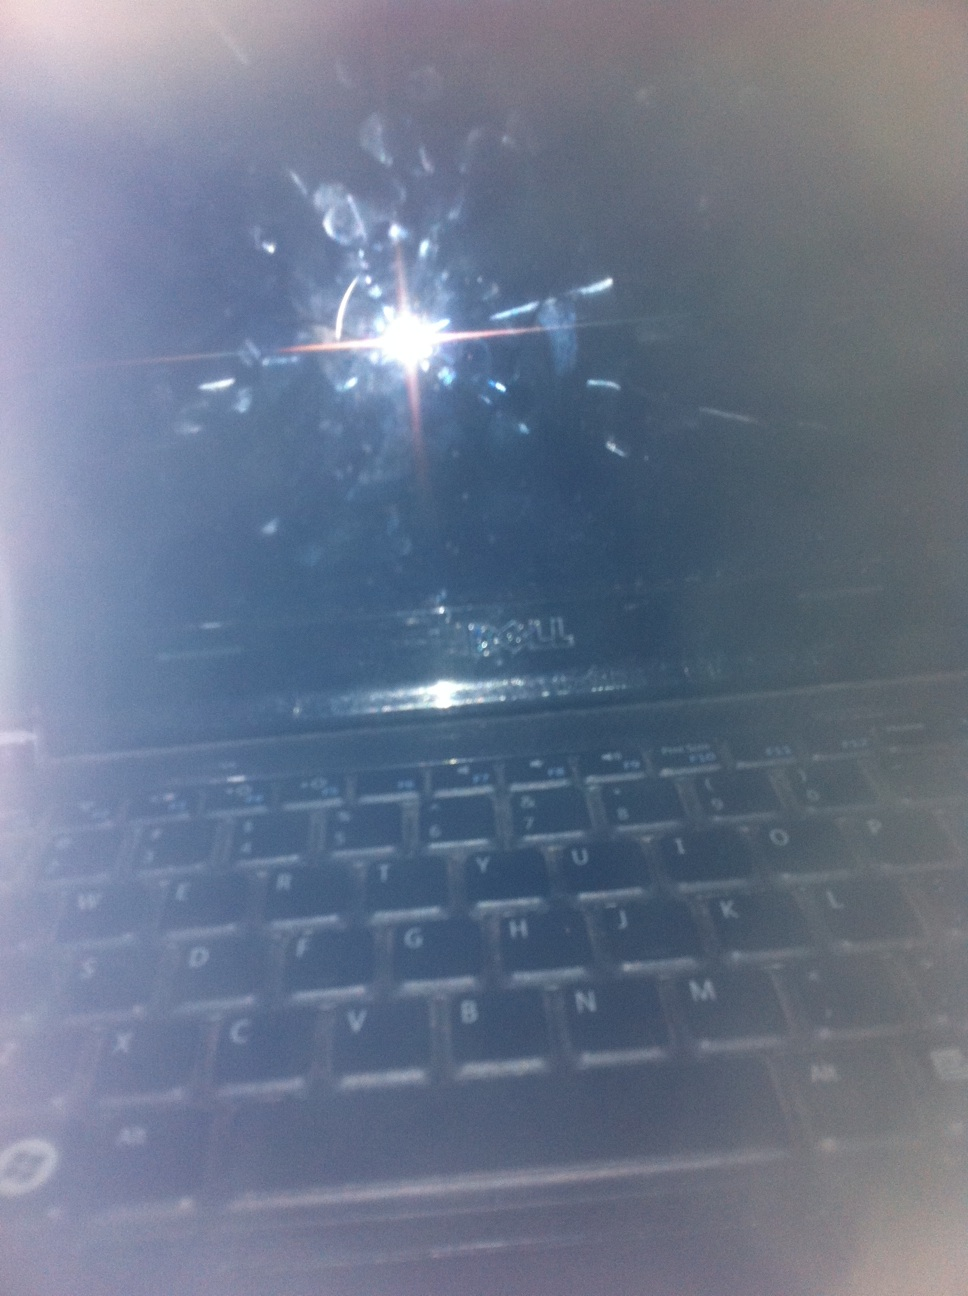Craft a realistic dialogue where this laptop breaks down in the middle of an important task. Human: "Not now, not now! We are so close!"
GPT: "What's wrong? Why is the screen black?"
Human: "I think it just crashed. We were right in the middle of decrypting that last batch of files. We can't afford to lose any time."
GPT: "Try restarting it. Maybe it will recover. But we need to act fast."
Human: "Hold on, I think there’s a backup on the external drive. Let’s plug it in and continue the work there." 